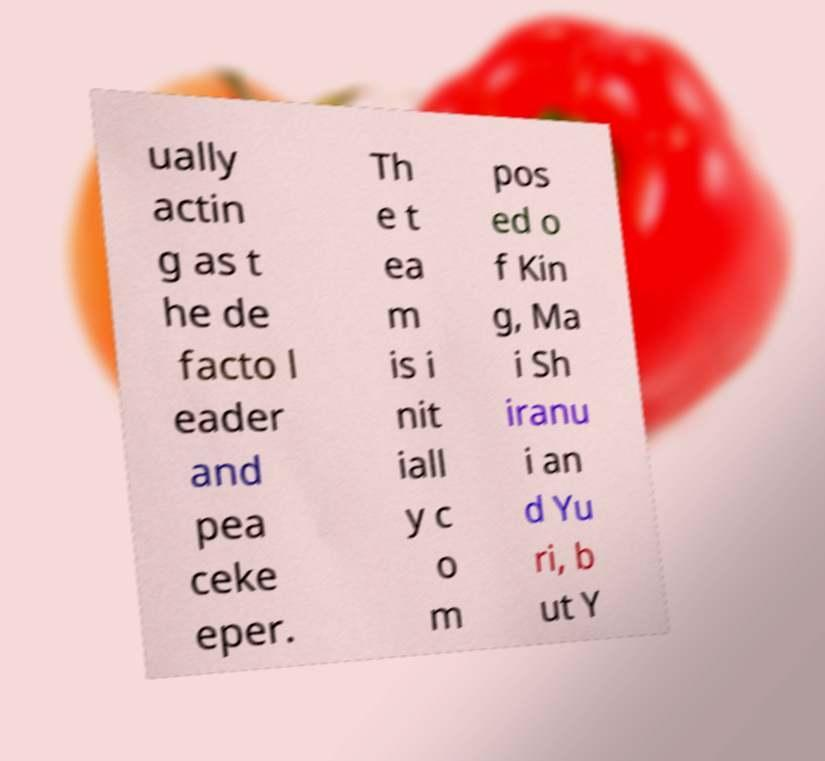I need the written content from this picture converted into text. Can you do that? ually actin g as t he de facto l eader and pea ceke eper. Th e t ea m is i nit iall y c o m pos ed o f Kin g, Ma i Sh iranu i an d Yu ri, b ut Y 